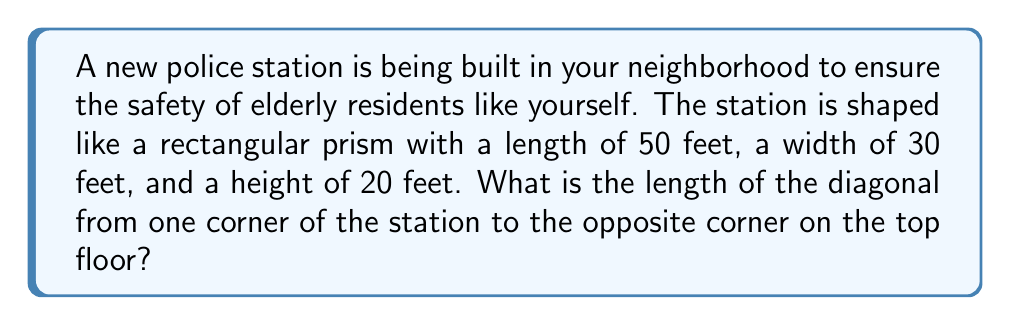Can you answer this question? To find the diagonal length of a rectangular prism, we can use the three-dimensional extension of the Pythagorean theorem. Let's approach this step-by-step:

1. First, let's visualize the prism:

[asy]
import three;
size(200);
currentprojection=perspective(6,3,2);
draw(cuboid((0,0,0),(50,30,20)),blue);
draw((0,0,0)--(50,30,20),red,Arrow3);
label("Diagonal",(25,15,10),N);
[/asy]

2. The diagonal of a rectangular prism can be calculated using the formula:

   $$d = \sqrt{l^2 + w^2 + h^2}$$

   Where $d$ is the diagonal length, $l$ is the length, $w$ is the width, and $h$ is the height.

3. Let's substitute our values:
   $l = 50$ feet
   $w = 30$ feet
   $h = 20$ feet

4. Now, let's plug these into our formula:

   $$d = \sqrt{50^2 + 30^2 + 20^2}$$

5. Simplify the squares:

   $$d = \sqrt{2500 + 900 + 400}$$

6. Add the numbers under the square root:

   $$d = \sqrt{3800}$$

7. Simplify the square root:

   $$d = 20\sqrt{95} \approx 61.64 \text{ feet}$$

Thus, the diagonal length of the police station is $20\sqrt{95}$ feet, or approximately 61.64 feet.
Answer: $20\sqrt{95}$ feet (approximately 61.64 feet) 